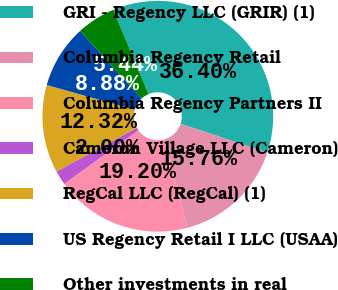Convert chart to OTSL. <chart><loc_0><loc_0><loc_500><loc_500><pie_chart><fcel>GRI - Regency LLC (GRIR) (1)<fcel>Columbia Regency Retail<fcel>Columbia Regency Partners II<fcel>Cameron Village LLC (Cameron)<fcel>RegCal LLC (RegCal) (1)<fcel>US Regency Retail I LLC (USAA)<fcel>Other investments in real<nl><fcel>36.4%<fcel>15.76%<fcel>19.2%<fcel>2.0%<fcel>12.32%<fcel>8.88%<fcel>5.44%<nl></chart> 